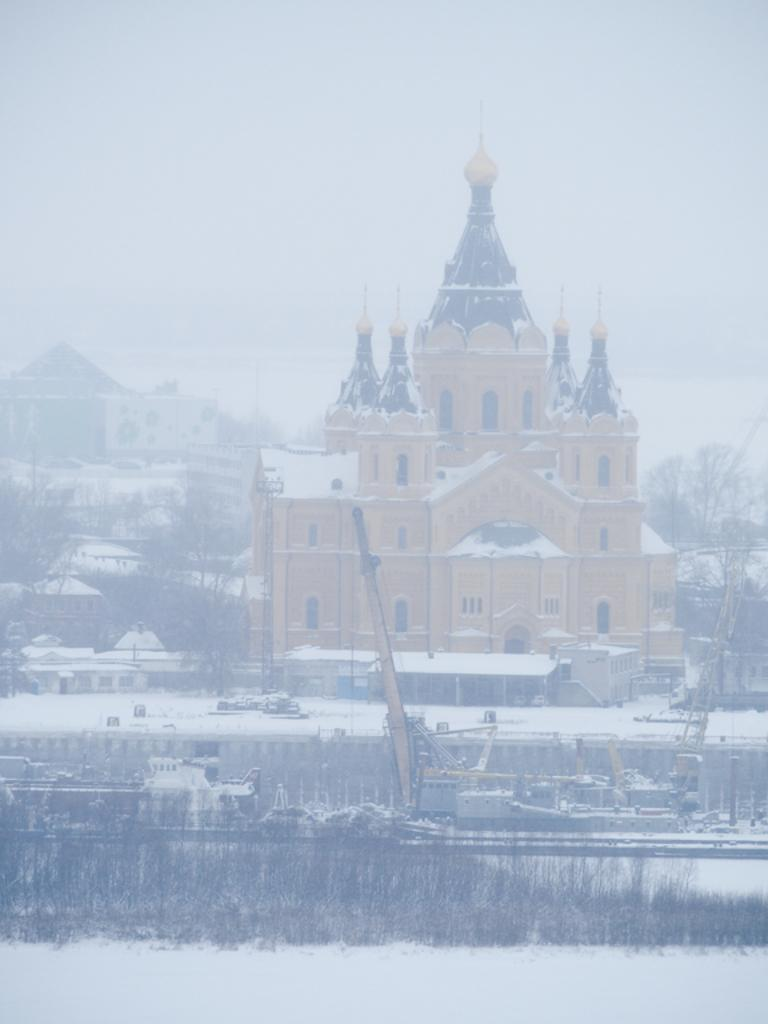What type of structures can be seen in the image? There are buildings and houses in the image. What natural elements are present in the image? There are trees and grass in the image. What construction equipment can be seen in the image? There are cranes in the image. What is the overall appearance of the image due to the weather? The image is covered with snow. What type of ornament is hanging from the trees in the image? There are no ornaments hanging from the trees in the image; it is covered with snow. What type of fruit can be seen growing on the grass in the image? There are no fruits growing on the grass in the image; it is covered with snow. 